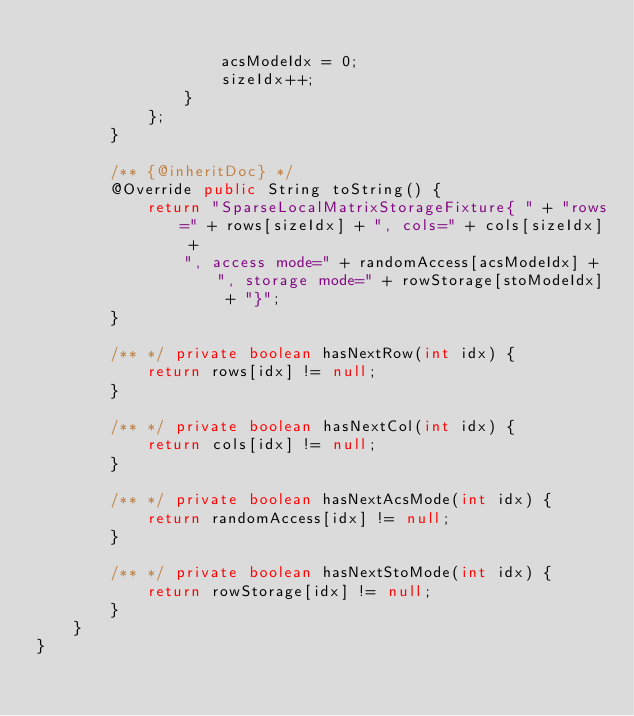Convert code to text. <code><loc_0><loc_0><loc_500><loc_500><_Java_>
                    acsModeIdx = 0;
                    sizeIdx++;
                }
            };
        }

        /** {@inheritDoc} */
        @Override public String toString() {
            return "SparseLocalMatrixStorageFixture{ " + "rows=" + rows[sizeIdx] + ", cols=" + cols[sizeIdx] +
                ", access mode=" + randomAccess[acsModeIdx] + ", storage mode=" + rowStorage[stoModeIdx] + "}";
        }

        /** */ private boolean hasNextRow(int idx) {
            return rows[idx] != null;
        }

        /** */ private boolean hasNextCol(int idx) {
            return cols[idx] != null;
        }

        /** */ private boolean hasNextAcsMode(int idx) {
            return randomAccess[idx] != null;
        }

        /** */ private boolean hasNextStoMode(int idx) {
            return rowStorage[idx] != null;
        }
    }
}
</code> 